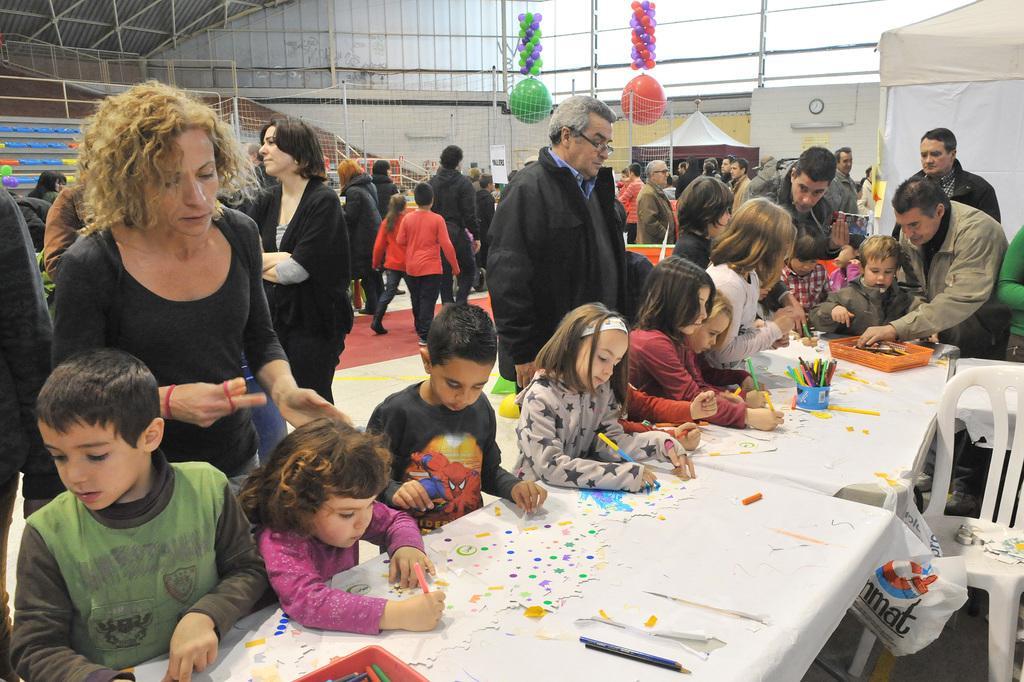In one or two sentences, can you explain what this image depicts? At the bottom of the image there is a table. On the table there are papers, color pencils and some other things. Behind the table there are few kids standing. Behind them there are many people standing. On the right side of the image there is a chair with few items on it. In the background there are poles with net, tents and also there are many other things. 